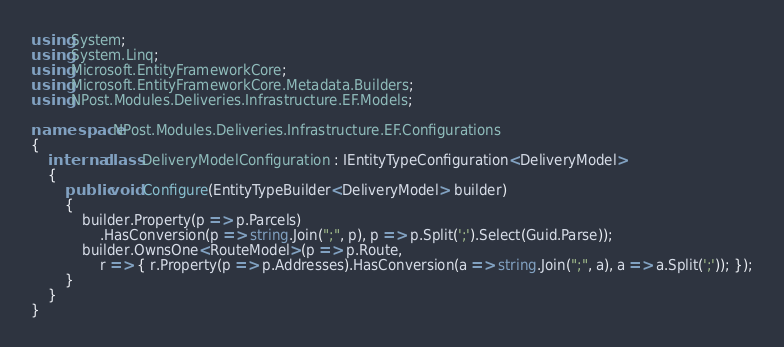<code> <loc_0><loc_0><loc_500><loc_500><_C#_>using System;
using System.Linq;
using Microsoft.EntityFrameworkCore;
using Microsoft.EntityFrameworkCore.Metadata.Builders;
using NPost.Modules.Deliveries.Infrastructure.EF.Models;

namespace NPost.Modules.Deliveries.Infrastructure.EF.Configurations
{
    internal class DeliveryModelConfiguration : IEntityTypeConfiguration<DeliveryModel>
    {
        public void Configure(EntityTypeBuilder<DeliveryModel> builder)
        {
            builder.Property(p => p.Parcels)
                .HasConversion(p => string.Join(";", p), p => p.Split(';').Select(Guid.Parse));
            builder.OwnsOne<RouteModel>(p => p.Route,
                r => { r.Property(p => p.Addresses).HasConversion(a => string.Join(";", a), a => a.Split(';')); });
        }
    }
}</code> 